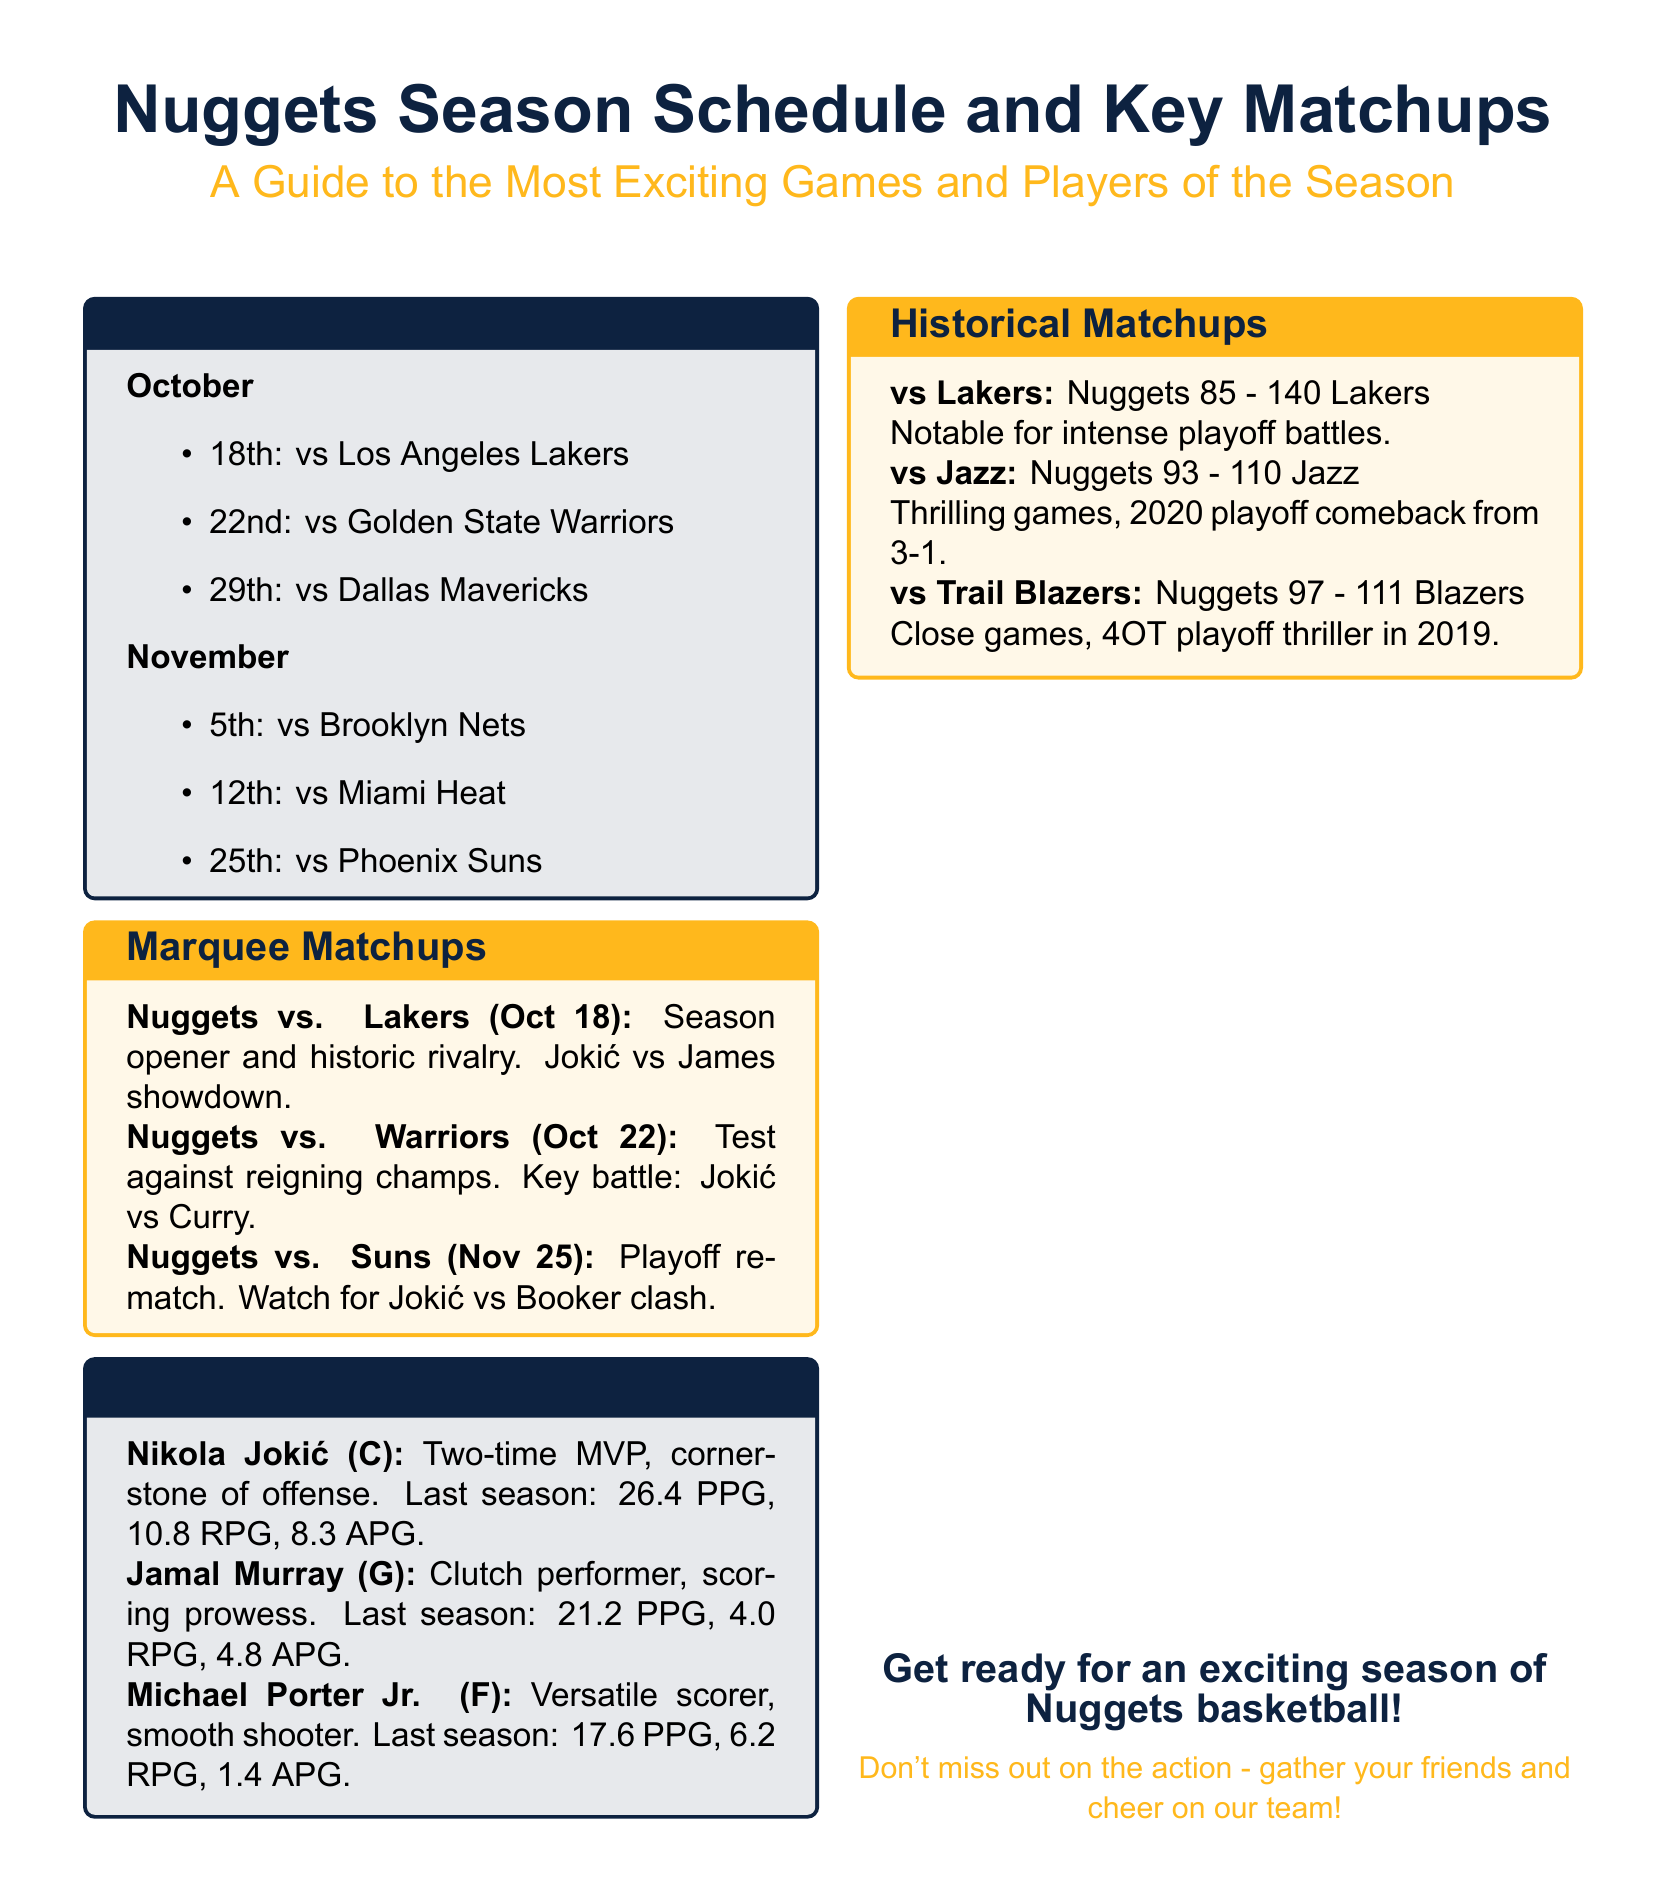What is the date of the season opener? The season opener is listed in the Season Calendar section as happening on October 18th.
Answer: October 18th Who are the key players mentioned in the Player Bios? The Player Bios section highlights three key players: Nikola Jokić, Jamal Murray, and Michael Porter Jr.
Answer: Nikola Jokić, Jamal Murray, Michael Porter Jr What was Nikola Jokić's average points per game last season? The Player Bios note that Jokić had an average of 26.4 PPG last season.
Answer: 26.4 PPG What is the matchup highlighted for November 25th? The Marquee Matchups section indicates that November 25th features a game against the Phoenix Suns.
Answer: vs. Suns Which team did the Nuggets face on October 22nd? The Season Calendar shows that on October 22nd the Nuggets are scheduled to play against the Golden State Warriors.
Answer: Golden State Warriors What is a notable historical matchup against the Lakers? The Historical Matchups section states that the Nuggets lost to the Lakers 85 - 140, notable for intense playoff battles.
Answer: 85 - 140 How many points per game did Jamal Murray average last season? The Player Bios indicate that Murray averaged 21.2 PPG last season.
Answer: 21.2 PPG What is a key battle to watch during the matchup against the Warriors? The document highlights that the key battle is Jokić vs Curry during the matchup against the Warriors.
Answer: Jokić vs Curry What color is used for the season schedule section background? The Season Calendar section uses a light blue color (nuggetsblue!10) for its background.
Answer: Light blue 